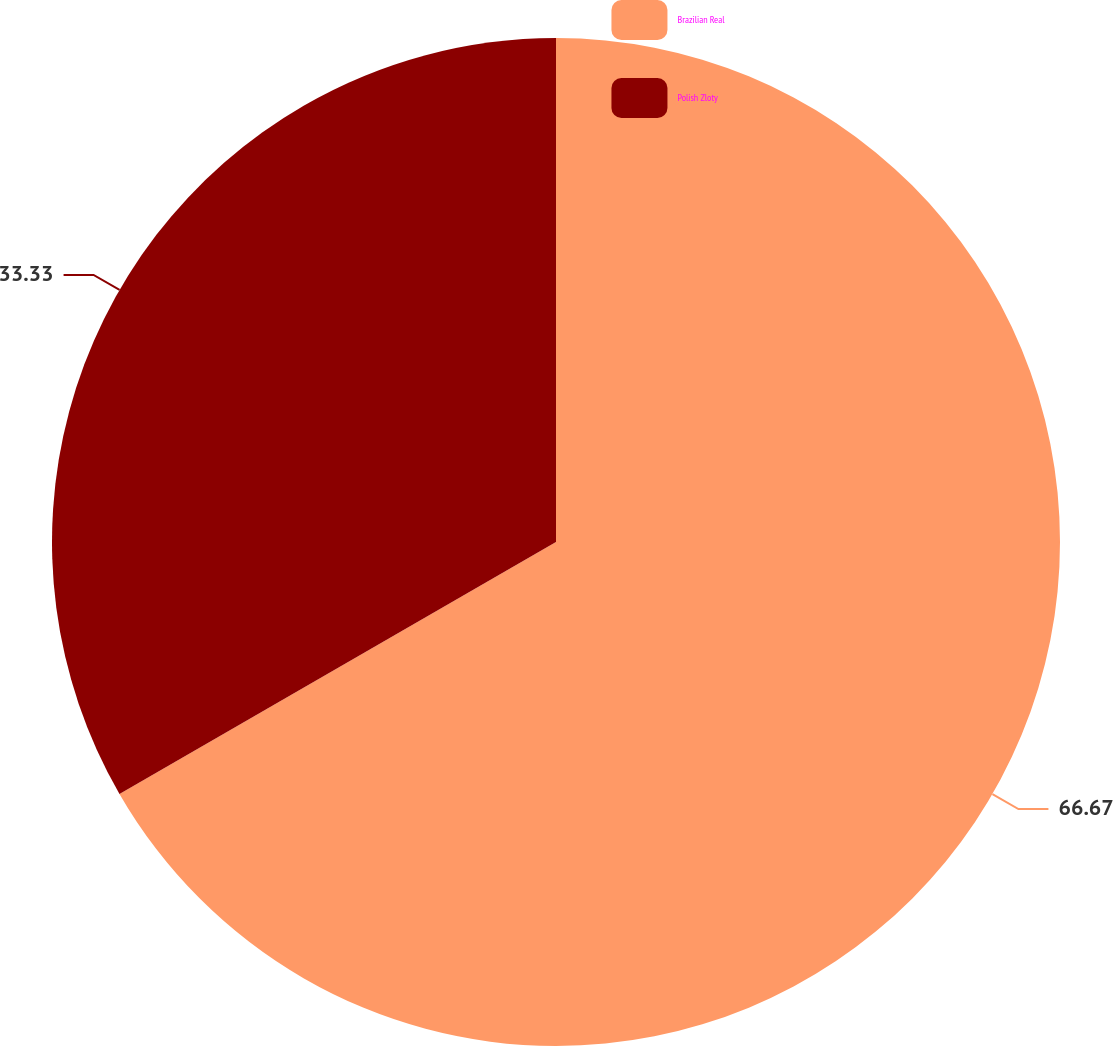Convert chart. <chart><loc_0><loc_0><loc_500><loc_500><pie_chart><fcel>Brazilian Real<fcel>Polish Zloty<nl><fcel>66.67%<fcel>33.33%<nl></chart> 